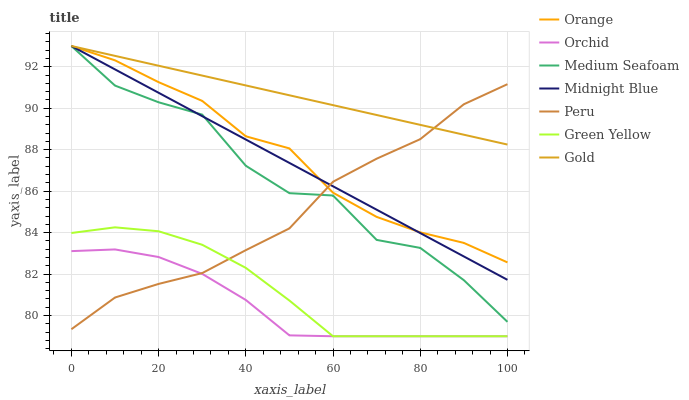Does Orchid have the minimum area under the curve?
Answer yes or no. Yes. Does Gold have the maximum area under the curve?
Answer yes or no. Yes. Does Peru have the minimum area under the curve?
Answer yes or no. No. Does Peru have the maximum area under the curve?
Answer yes or no. No. Is Gold the smoothest?
Answer yes or no. Yes. Is Medium Seafoam the roughest?
Answer yes or no. Yes. Is Peru the smoothest?
Answer yes or no. No. Is Peru the roughest?
Answer yes or no. No. Does Green Yellow have the lowest value?
Answer yes or no. Yes. Does Peru have the lowest value?
Answer yes or no. No. Does Medium Seafoam have the highest value?
Answer yes or no. Yes. Does Peru have the highest value?
Answer yes or no. No. Is Orchid less than Medium Seafoam?
Answer yes or no. Yes. Is Gold greater than Orchid?
Answer yes or no. Yes. Does Peru intersect Orchid?
Answer yes or no. Yes. Is Peru less than Orchid?
Answer yes or no. No. Is Peru greater than Orchid?
Answer yes or no. No. Does Orchid intersect Medium Seafoam?
Answer yes or no. No. 